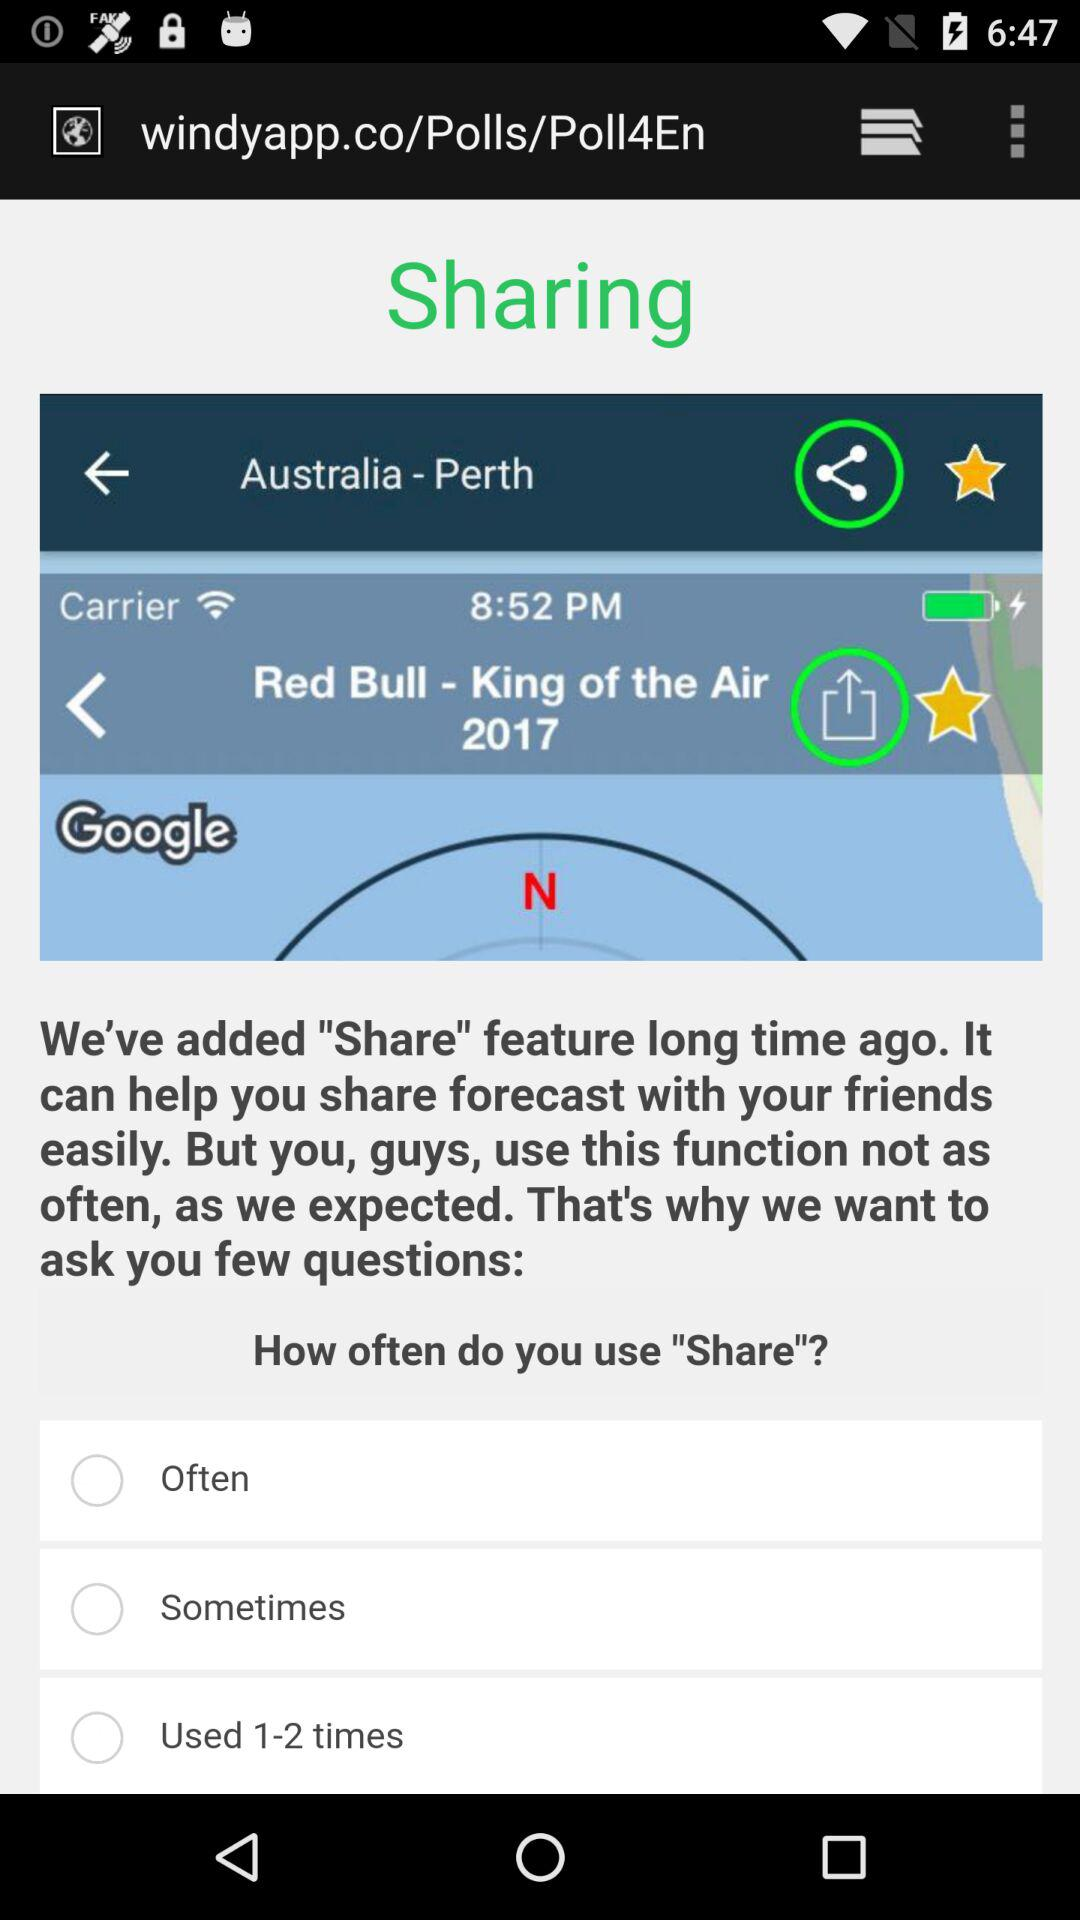What country is mentioned? The mentioned country is Australia. 